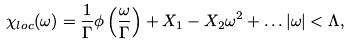<formula> <loc_0><loc_0><loc_500><loc_500>\chi _ { l o c } ( \omega ) = \frac { 1 } { \Gamma } \phi \left ( \frac { \omega } { \Gamma } \right ) + X _ { 1 } - X _ { 2 } \omega ^ { 2 } + \dots | \omega | < \Lambda ,</formula> 